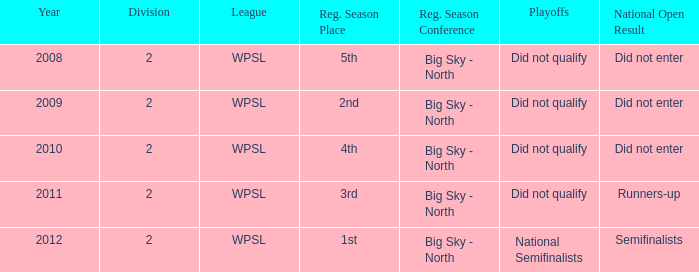What was the regular season name where they did not qualify for the playoffs in 2009? 2nd, Big Sky - North. 